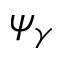Convert formula to latex. <formula><loc_0><loc_0><loc_500><loc_500>\psi _ { \gamma }</formula> 